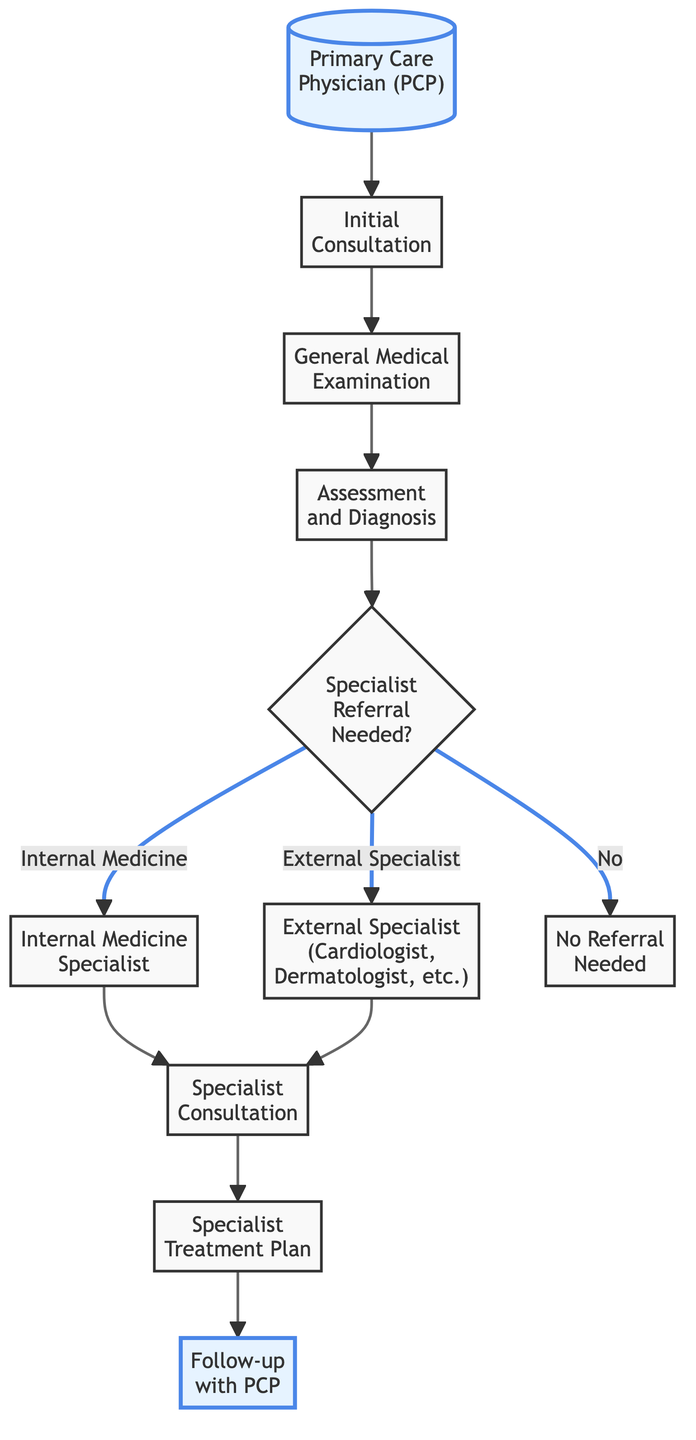What's the first step in the referral process? The first step is "Primary Care Physician (PCP)". This node indicates the starting point of the healthcare pathway.
Answer: Primary Care Physician (PCP) How many nodes are in the diagram? There are 11 nodes present in the diagram that represent different steps and decisions in the referral process.
Answer: 11 What happens after the "Assessment and Diagnosis"? After "Assessment and Diagnosis", the flow goes to the node labeled "Specialist Referral Needed?". This node indicates whether a referral to a specialist is required.
Answer: Specialist Referral Needed? What are the two paths available if a specialist referral is needed? If a specialist referral is needed, there are two paths: one leading to "Internal Medicine Specialist" and the other leading to "External Specialist (Cardiologist, Dermatologist, etc.)". This shows the two types of specialists to whom patients can be referred.
Answer: Internal Medicine Specialist and External Specialist What is the outcome if no referral is needed? If no referral is needed, the flow goes directly to the node labeled "No Referral Needed" indicating that the patient does not require additional specialist care.
Answer: No Referral Needed What is the last step in the process after a specialist consultation? The last step in the process after a specialist consultation is "Follow-up with PCP". This step ensures communication and continuity of care between the patient and the primary care physician after specialist treatment.
Answer: Follow-up with PCP What is the relationship between "Specialist Consultation" and "Specialist Treatment Plan"? "Specialist Consultation" is followed by "Specialist Treatment Plan", indicating that once a specialist consultation occurs, a treatment plan is developed based on the consultation findings.
Answer: Specialist Consultation followed by Specialist Treatment Plan Which node indicates the decision for needing a specialist? The node "Specialist Referral Needed?" indicates the decision point for determining whether a specialist is required for further care.
Answer: Specialist Referral Needed? 